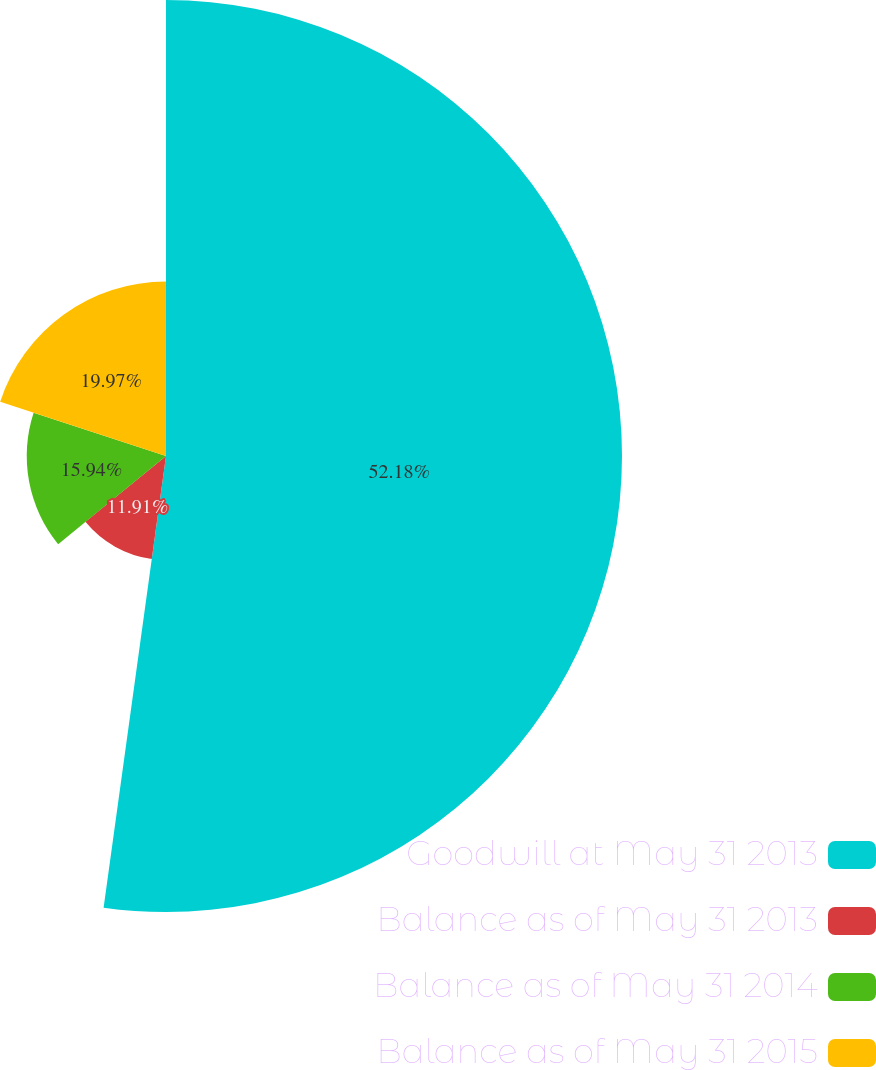Convert chart to OTSL. <chart><loc_0><loc_0><loc_500><loc_500><pie_chart><fcel>Goodwill at May 31 2013<fcel>Balance as of May 31 2013<fcel>Balance as of May 31 2014<fcel>Balance as of May 31 2015<nl><fcel>52.19%<fcel>11.91%<fcel>15.94%<fcel>19.97%<nl></chart> 